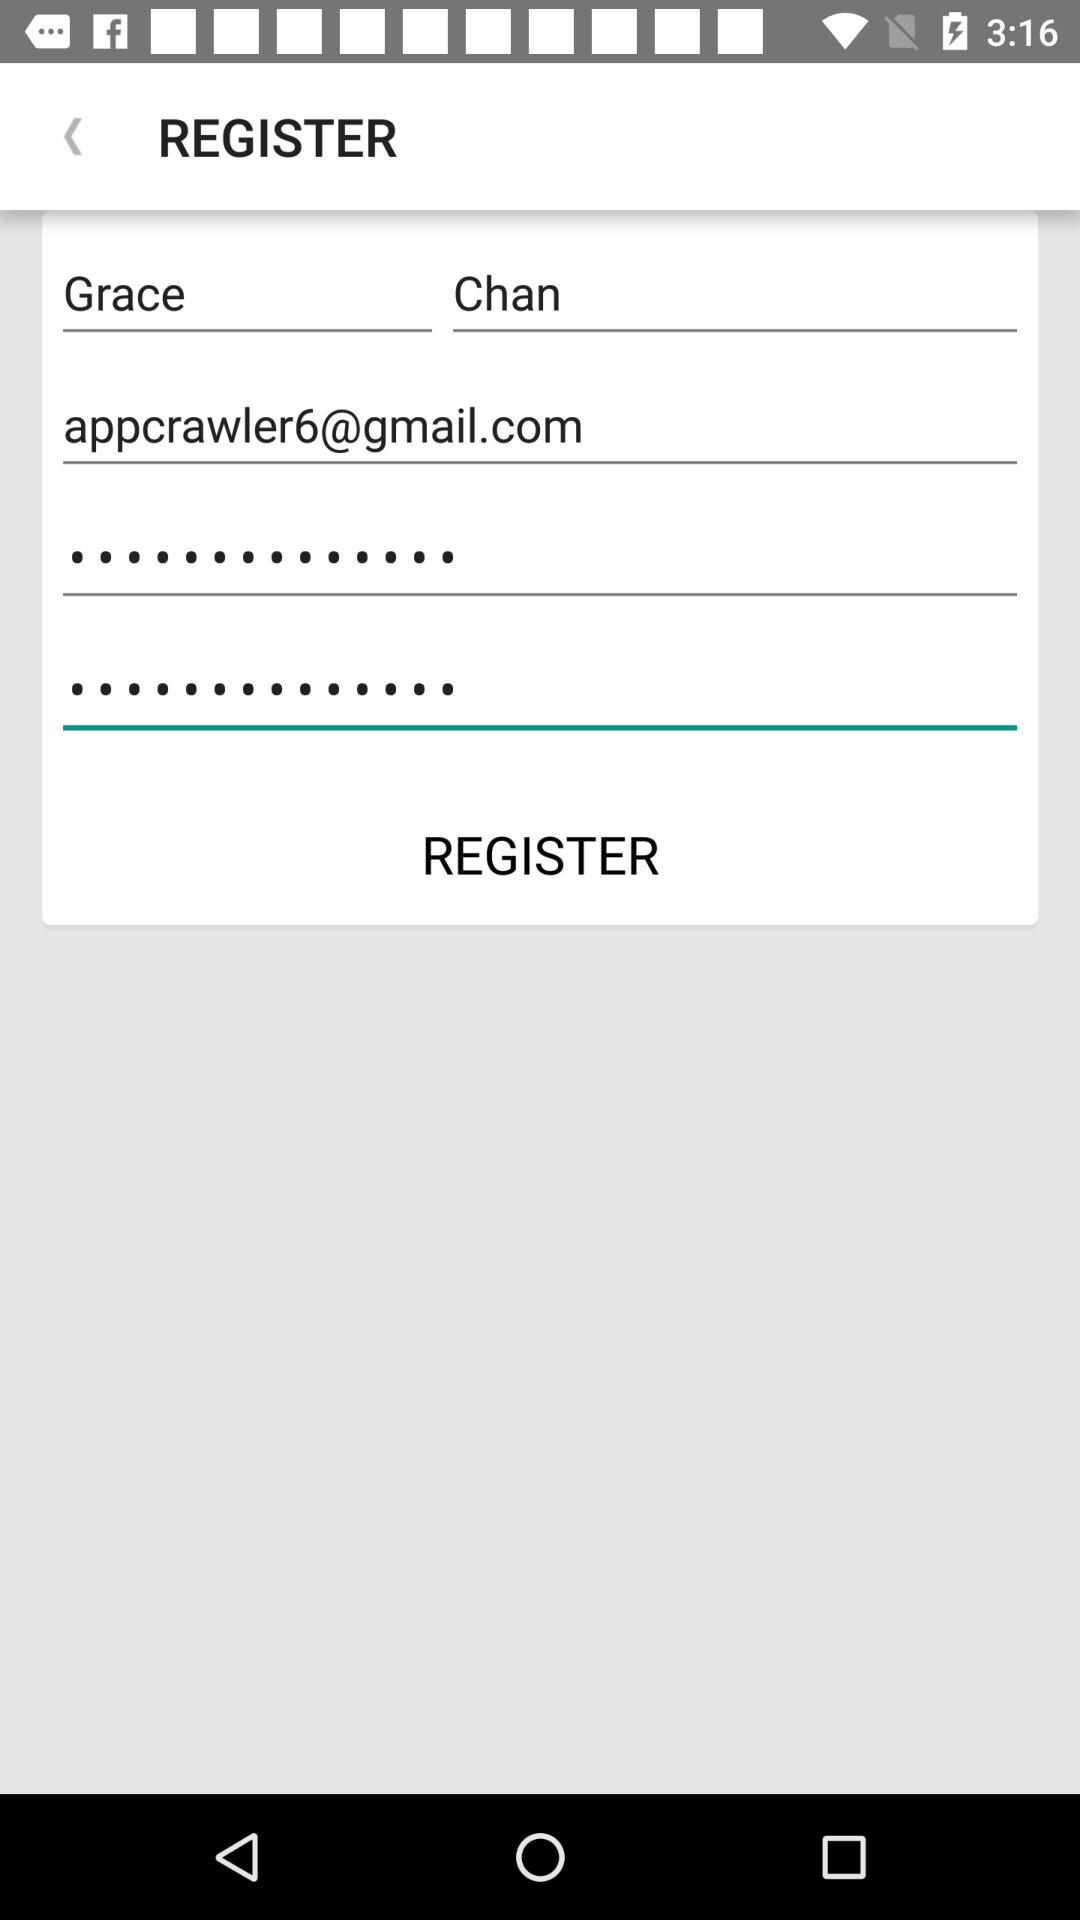What is the name? The name is Grace Chan. 